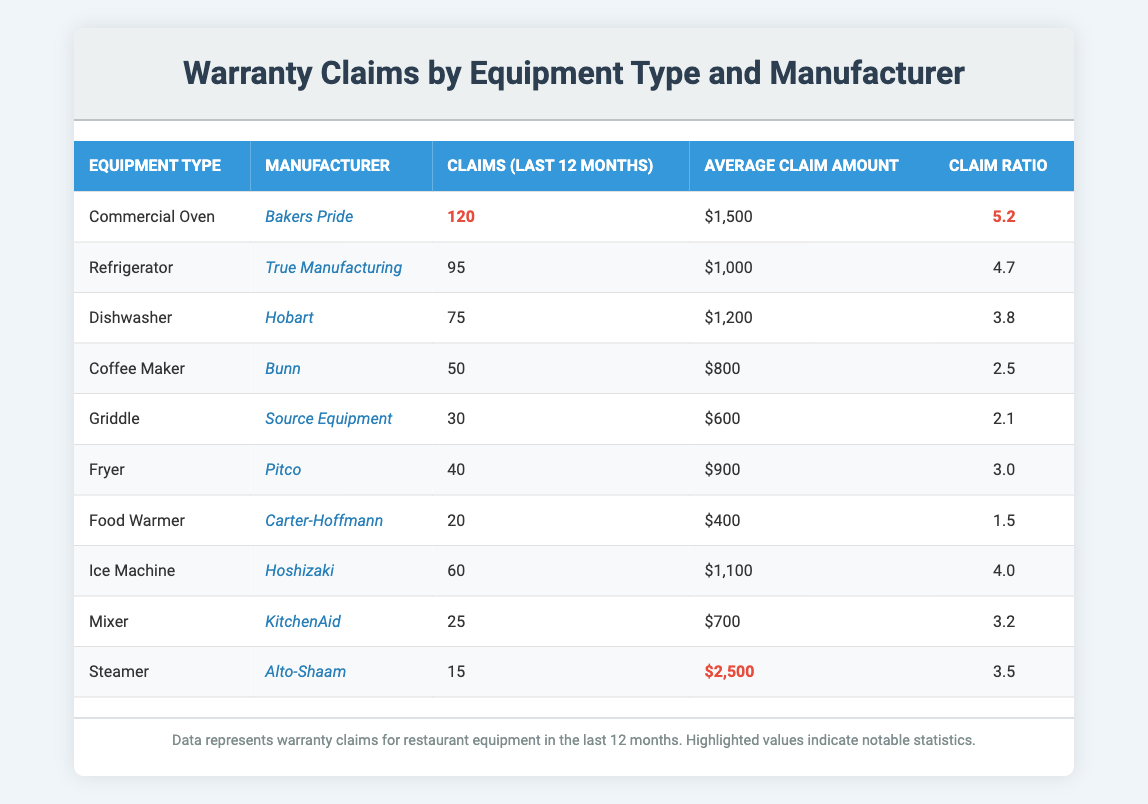What is the total number of warranty claims for the "Commercial Oven"? The specific value for claims related to the "Commercial Oven" is highlighted in the table and shown as 120.
Answer: 120 Which manufacturer has the highest average claim amount? The average claim amounts for each manufacturer are listed. The "Steamer" from Alto-Shaam has the highest average claim amount of $2,500 compared to others.
Answer: Alto-Shaam How many claims were made for the "Dishwasher"? The table provides the number of claims made for the "Dishwasher," which is stated as 75.
Answer: 75 What is the claim ratio for "Food Warmer"? The claim ratio for the "Food Warmer" is explicitly mentioned in the table and is 1.5.
Answer: 1.5 If we sum the claims of "Griddle" and "Fryer," what do we get? The claims for "Griddle" is 30 and for "Fryer" is 40. Adding them yields 30 + 40 = 70.
Answer: 70 Which equipment type has the lowest number of claims? By comparing the claims across all equipment types listed, "Steamer" has the lowest claims with a value of 15.
Answer: Steamer Is the average claim amount for "Refrigerator" higher than that of "Fryer"? The average claim amount for "Refrigerator" is $1,000 and for "Fryer" is $900. Since $1,000 is greater than $900, the statement is true.
Answer: Yes Calculate the average claim amount for the top three equipment types by claims. The top three equipment types by claims are "Commercial Oven" (120), "Refrigerator" (95), and "Dishwasher" (75). Their average claim amounts are $1,500, $1,000, and $1,200 respectively. The total is $1,500 + $1,000 + $1,200 = $3,700, and the average is $3,700 / 3 = $1,233.33.
Answer: $1,233.33 Which manufacturer has the highest claim ratio? Upon reviewing the claim ratios, "Bakers Pride" has the highest claim ratio at 5.2, compared to other manufacturers.
Answer: Bakers Pride Is it true that more than 50 claims were made for both "Ice Machine" and "Dishwasher"? The table shows "Ice Machine" has 60 claims and "Dishwasher" has 75 claims, both exceeding 50 claims, so the statement is true.
Answer: Yes What is the difference in claims between "Coffee Maker" and "Mixer"? The claims for "Coffee Maker" are 50 and for "Mixer" are 25. The difference is calculated by subtracting: 50 - 25 = 25.
Answer: 25 